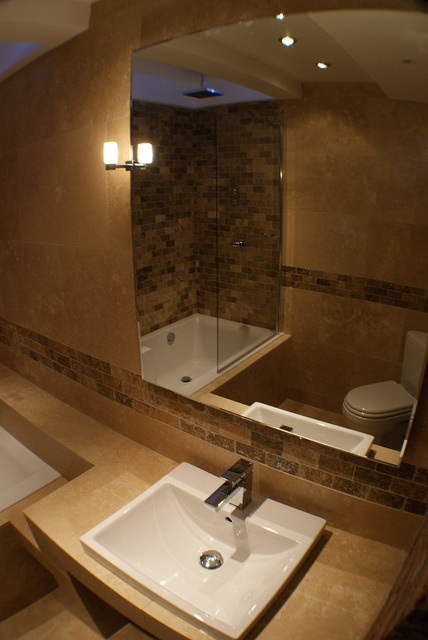Describe the objects in this image and their specific colors. I can see sink in black, tan, and lightgray tones, toilet in black, maroon, and gray tones, and sink in black and tan tones in this image. 